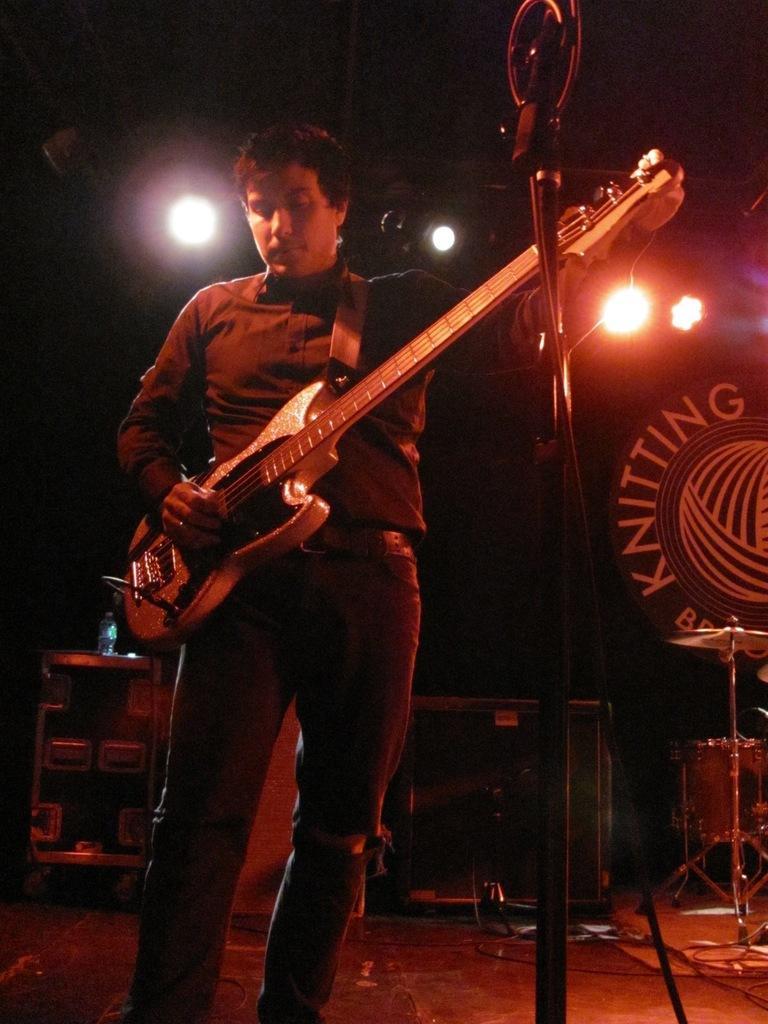Can you describe this image briefly? Here we can see a person standing on the floor, and holding a guitar in his hand and in front here is the stand, and at above here are the lights. 